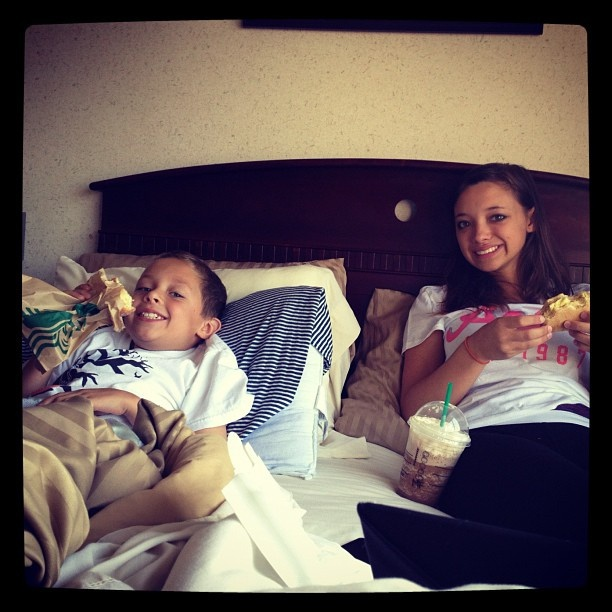Describe the objects in this image and their specific colors. I can see bed in black, beige, gray, and darkgray tones, people in black, brown, darkgray, and purple tones, people in black, gray, beige, and tan tones, cup in black, beige, purple, darkgray, and brown tones, and sandwich in black, tan, brown, and khaki tones in this image. 